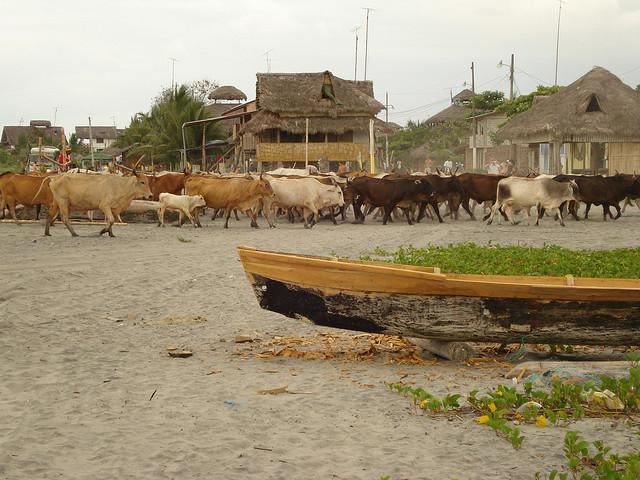What roofing method was used on these houses? Please explain your reasoning. thatching. The houses' rooftops have thatching. 